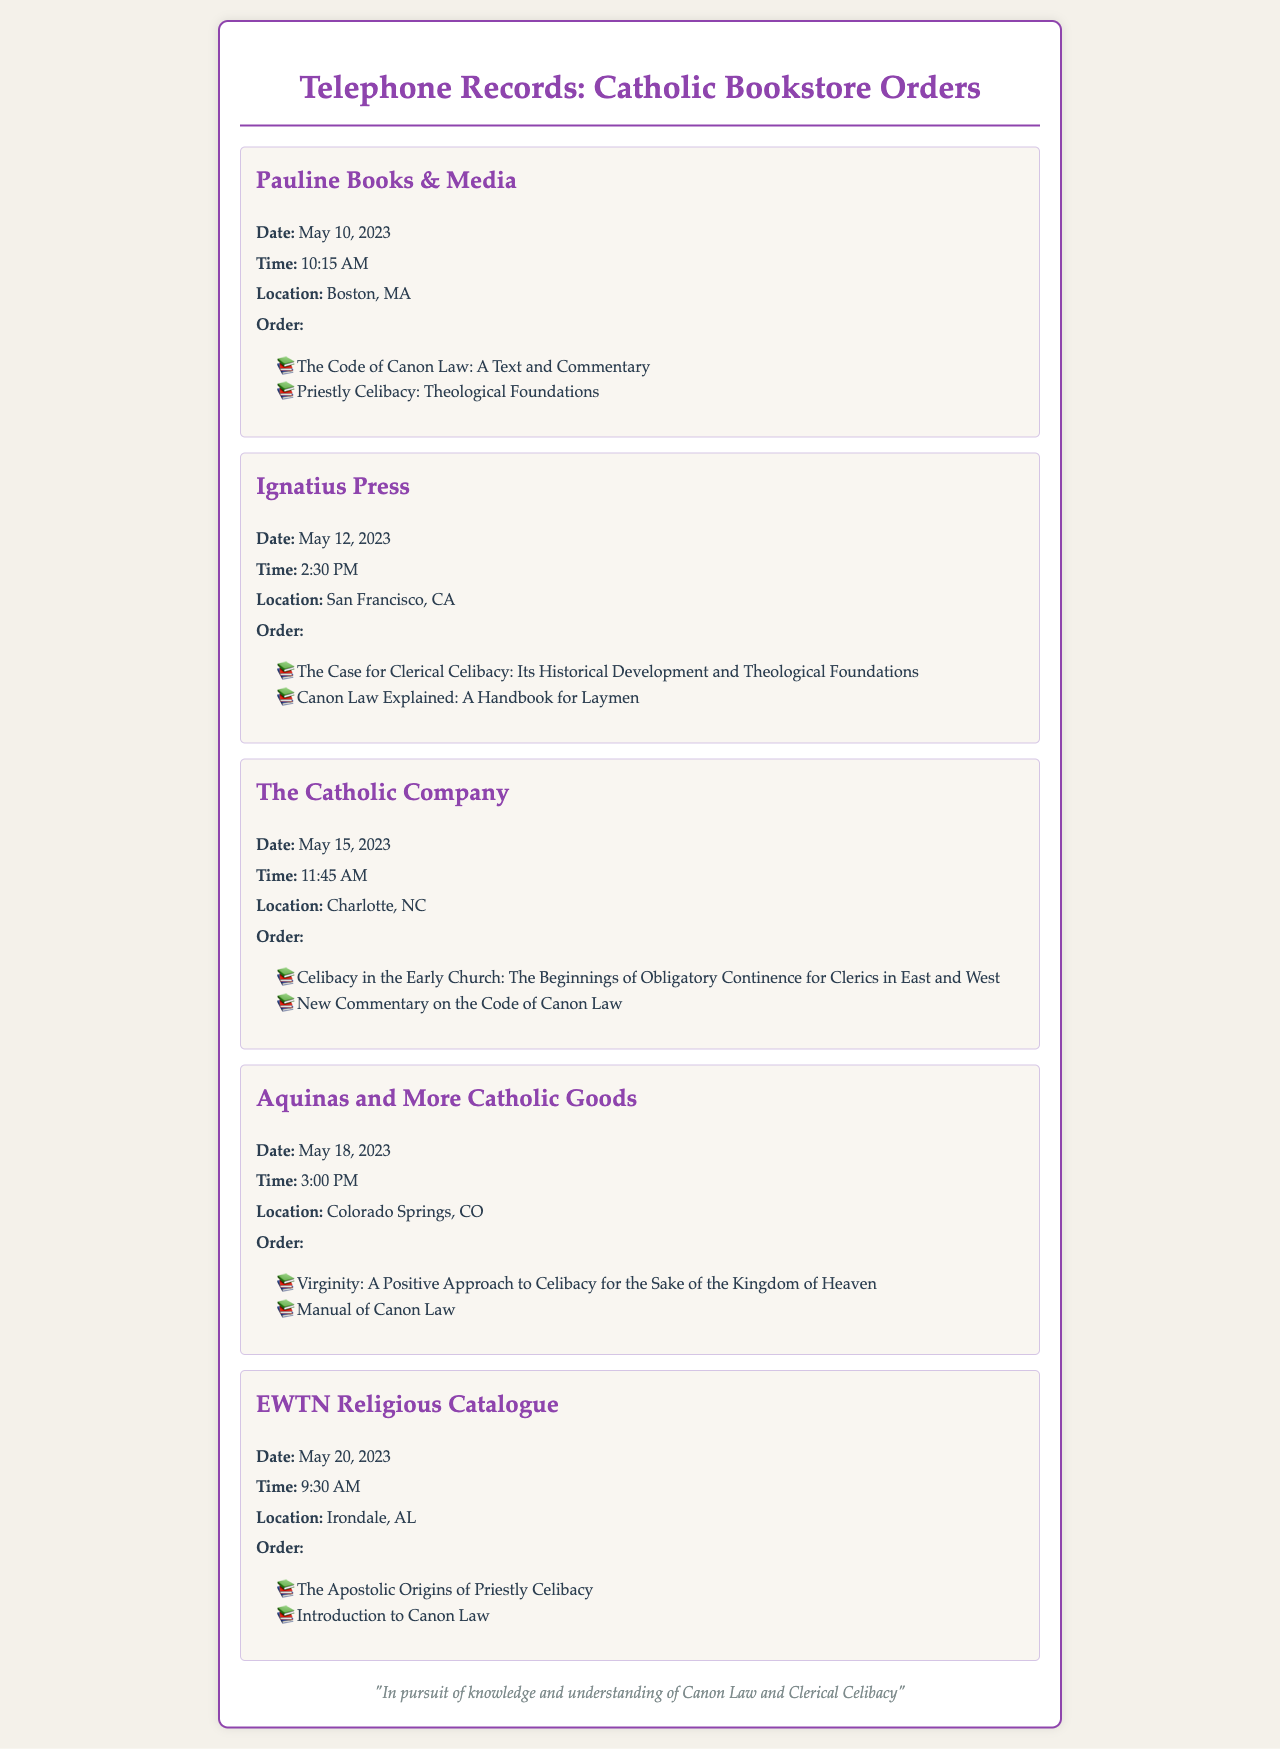what is the name of the first bookstore in the records? The first bookstore listed in the records is Pauline Books & Media.
Answer: Pauline Books & Media what is the order date for Ignatius Press? The order date for Ignatius Press is May 12, 2023.
Answer: May 12, 2023 how many books were ordered from The Catholic Company? Two books were ordered from The Catholic Company.
Answer: Two what is one of the titles ordered from EWTN Religious Catalogue? One of the titles ordered from EWTN Religious Catalogue is The Apostolic Origins of Priestly Celibacy.
Answer: The Apostolic Origins of Priestly Celibacy what is the time of the order from Aquinas and More Catholic Goods? The time of the order from Aquinas and More Catholic Goods is 3:00 PM.
Answer: 3:00 PM which bookstore is located in Boston, MA? The bookstore located in Boston, MA is Pauline Books & Media.
Answer: Pauline Books & Media what is the common theme of the texts ordered across the records? The common theme of the texts ordered is clerical celibacy and canon law.
Answer: clerical celibacy and canon law how many different bookstores are mentioned in the records? There are five different bookstores mentioned in the records.
Answer: Five what city is associated with the third order? The city associated with the third order (The Catholic Company) is Charlotte, NC.
Answer: Charlotte, NC 